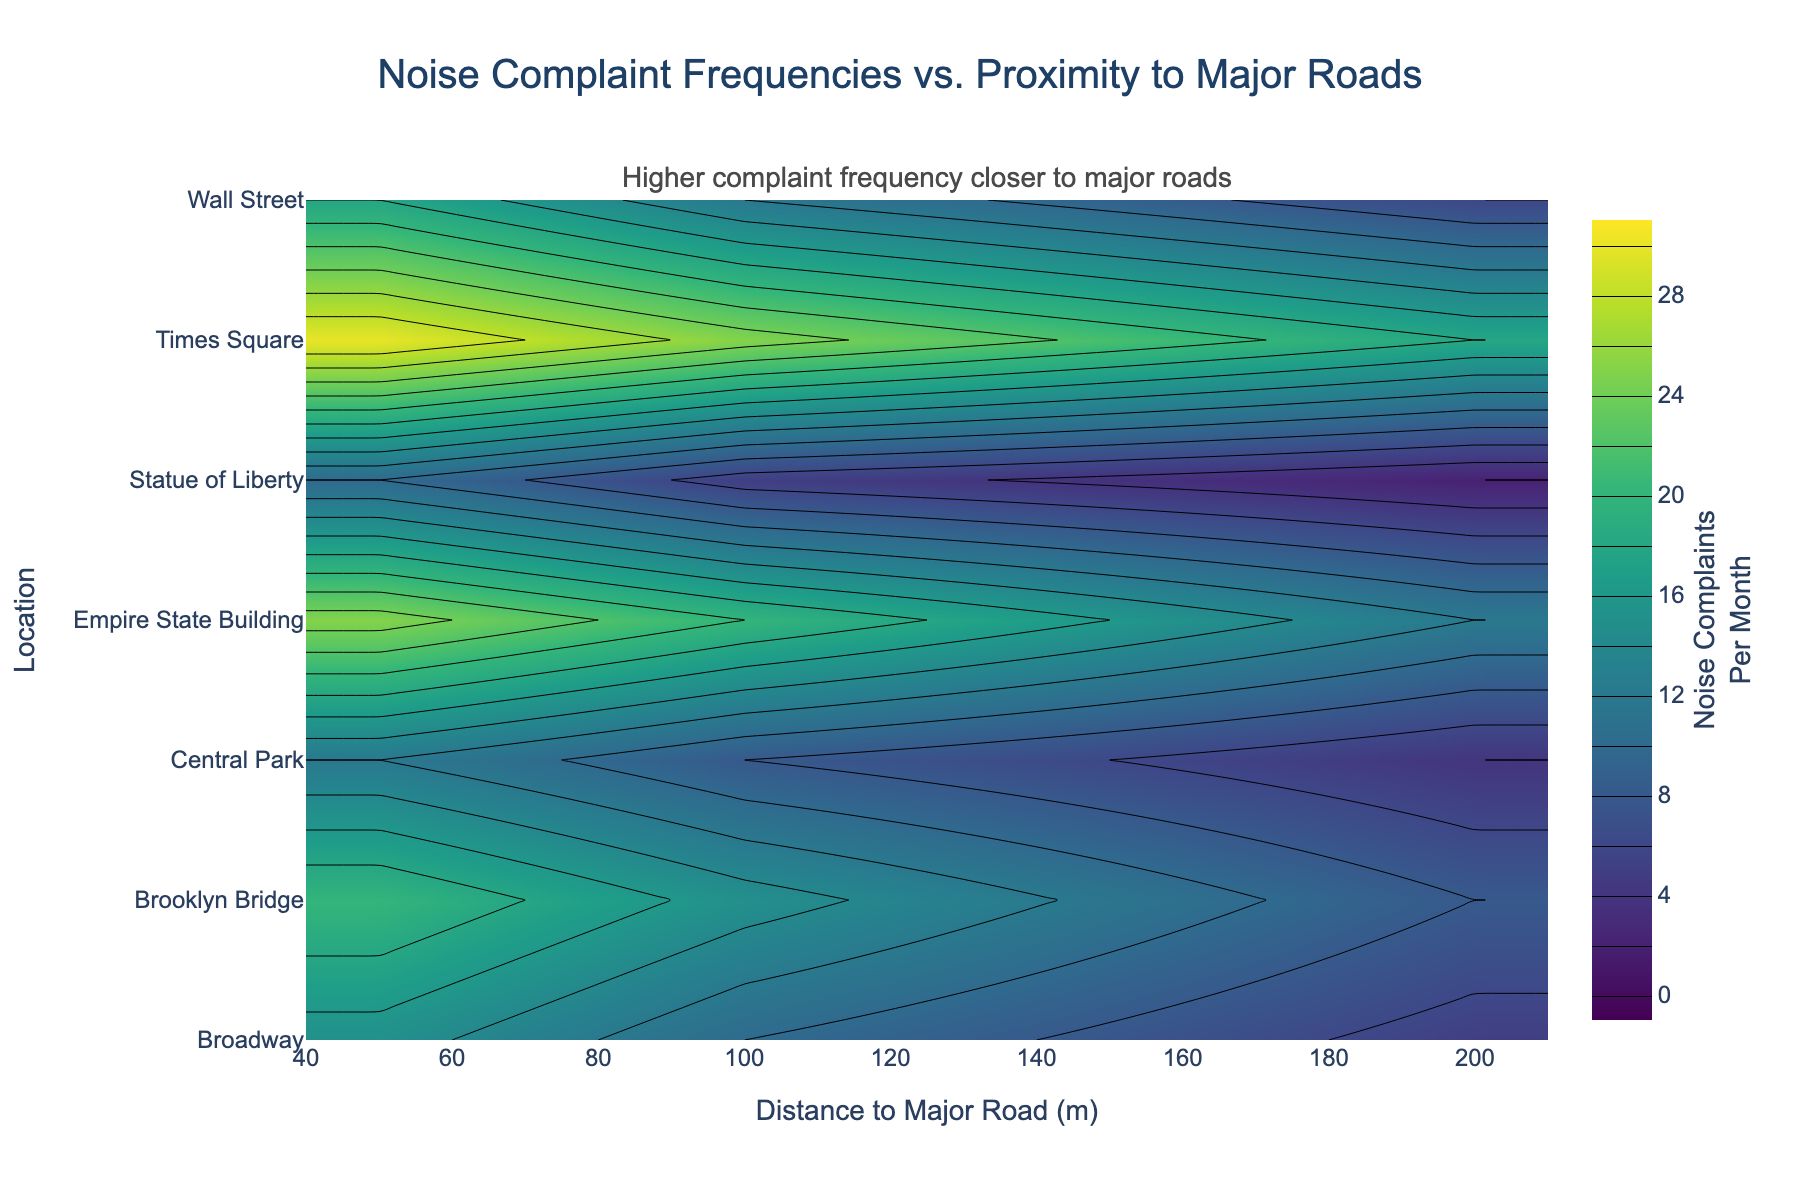What's the title of the figure? The title is usually displayed at the top of the figure. Here, the title is "Noise Complaint Frequencies vs. Proximity to Major Roads," which is stated clearly in the code provided for generating the plot.
Answer: Noise Complaint Frequencies vs. Proximity to Major Roads What is measured on the x-axis? The x-axis represents the distance to major roads in meters. This is indicated by the label "Distance to Major Road (m)" on the x-axis.
Answer: Distance to major roads (m) What does the color intensity indicate in the plot? The color intensity indicates the number of noise complaints per month. Darker colors represent higher frequencies, while lighter colors represent lower frequencies. This is evident from the annotation and the color bar labeled "Noise Complaints Per Month".
Answer: Number of noise complaints per month Which location has the highest noise complaint frequency at 50 meters distance to major roads? By identifying the darkest contour at the 50 meter distance along the y-axis, we can see that Times Square has the highest noise complaint frequency at this distance.
Answer: Times Square How does the complaint frequency change as you move from 50m to 200m distance at the Empire State Building? By following the contour lines across the x-axis from 50m to 200m for the Empire State Building, it is apparent that the noise complaints decrease from about 25 to 12.
Answer: Decreases from 25 to 12 Is the trend of decreasing complaints with increasing distance consistent across all locations? Checking the contours for each location demonstrates a general pattern: noise complaints decrease as the distance to major roads increases. This trend holds for all locations, indicating consistency.
Answer: Yes, it is consistent Compare the complaint frequencies at 100m distance between Brooklyn Bridge and Broadway. By locating 100m on the x-axis, we can see from the contours that Brooklyn Bridge has about 15 complaints, while Broadway has about 10 complaints, indicating Brooklyn Bridge has higher complaints at this distance.
Answer: Brooklyn Bridge has higher complaints What does the annotation 'Higher complaint frequency closer to major roads' suggest about the data? The annotation suggests there's a noticeable trend where noise complaint frequencies are higher near major roads (at 50m) and decrease as the distance increases, confirmed by examining the contour intensity patterns.
Answer: Complaints are higher near major roads Which location has the lowest noise complaint frequency at 200 meters distance? By identifying the lightest contour color at the 200 meter distance, it can be seen that the Statue of Liberty has the lowest noise complaint frequency at this distance.
Answer: Statue of Liberty 